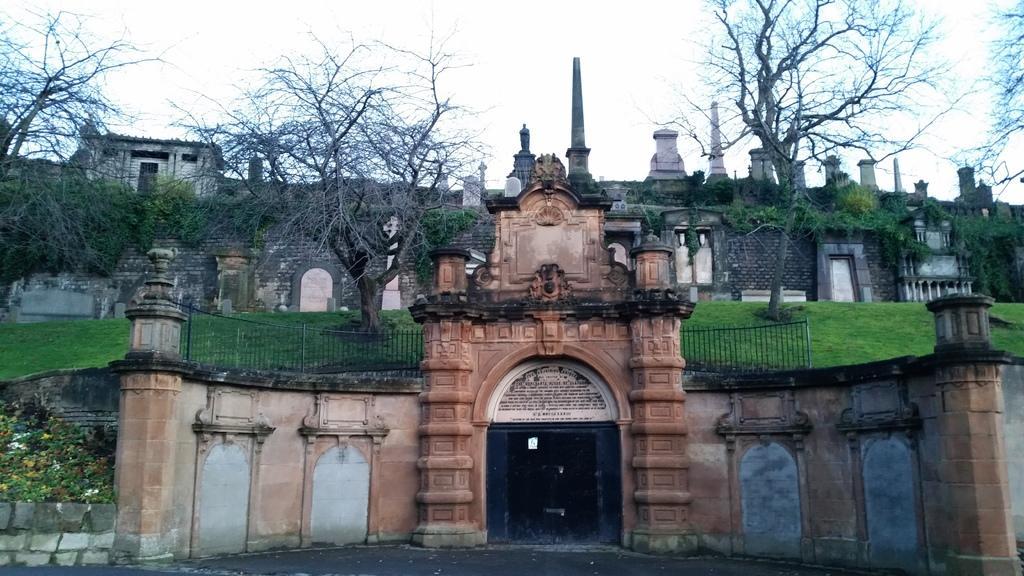Could you give a brief overview of what you see in this image? In this image I can see the buildings. On both sides I can see the railing and trees. To the left I can see the flowers to the plants. In the background I can see the sky. 